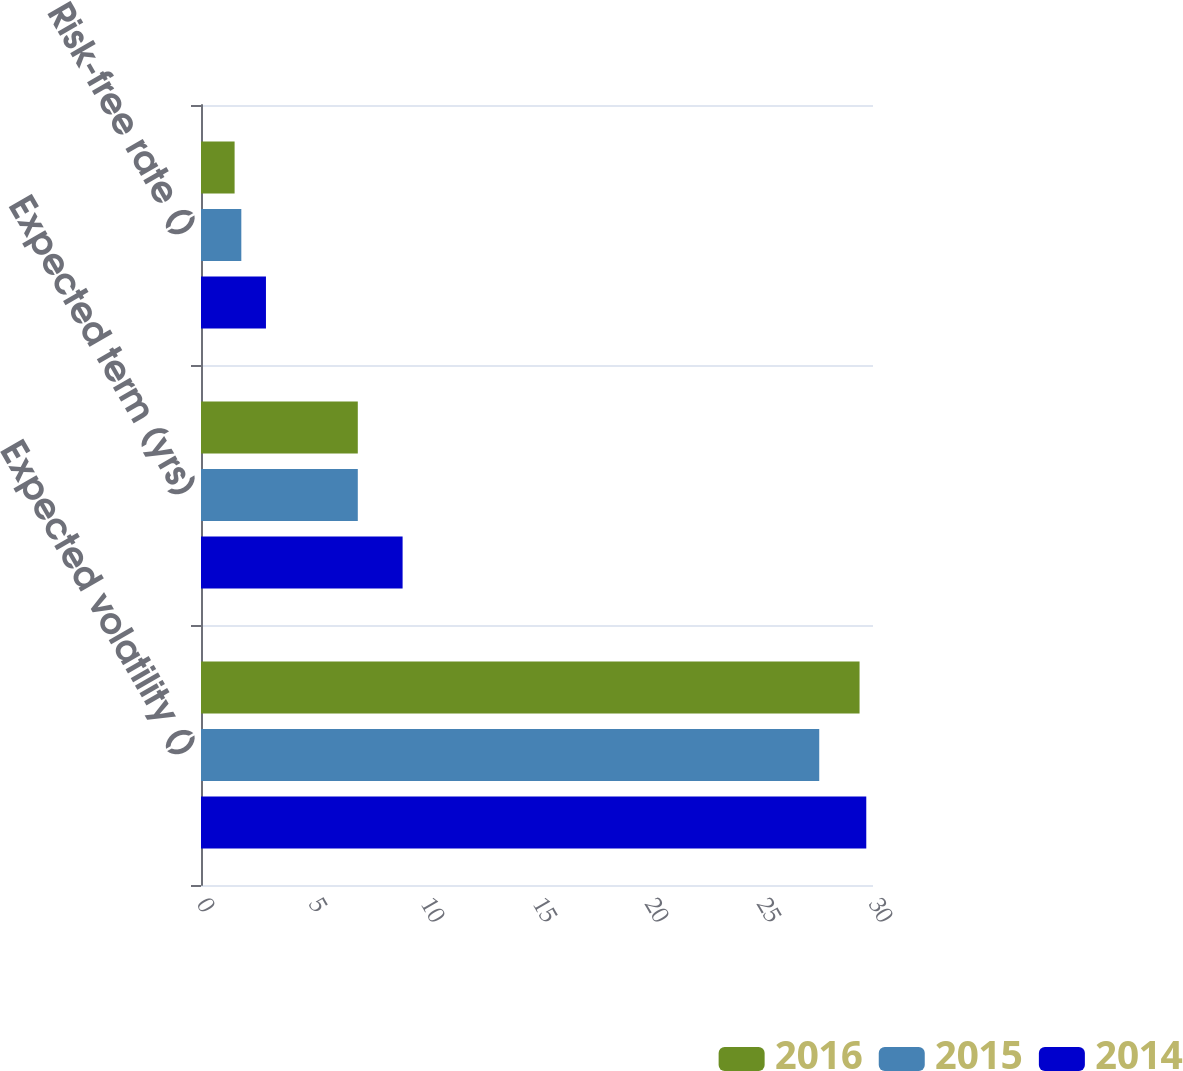Convert chart to OTSL. <chart><loc_0><loc_0><loc_500><loc_500><stacked_bar_chart><ecel><fcel>Expected volatility ()<fcel>Expected term (yrs)<fcel>Risk-free rate ()<nl><fcel>2016<fcel>29.4<fcel>7<fcel>1.5<nl><fcel>2015<fcel>27.6<fcel>7<fcel>1.8<nl><fcel>2014<fcel>29.7<fcel>9<fcel>2.9<nl></chart> 